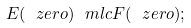Convert formula to latex. <formula><loc_0><loc_0><loc_500><loc_500>E ( \ z e r o ) \ m l c F ( \ z e r o ) ;</formula> 